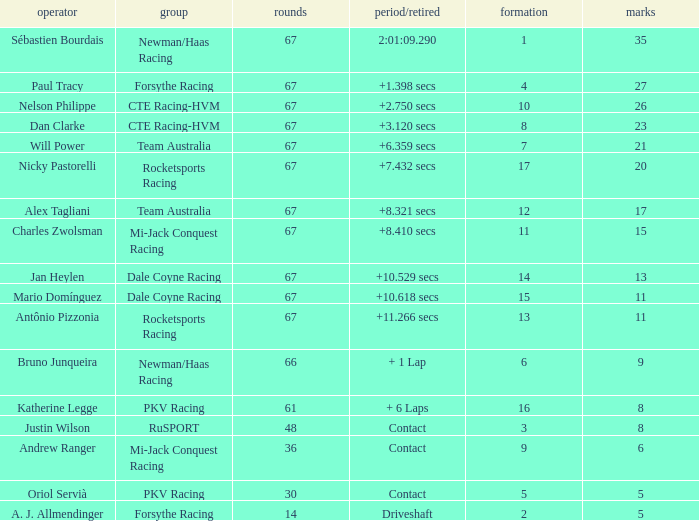What was time/retired with less than 67 laps and 6 points? Contact. 